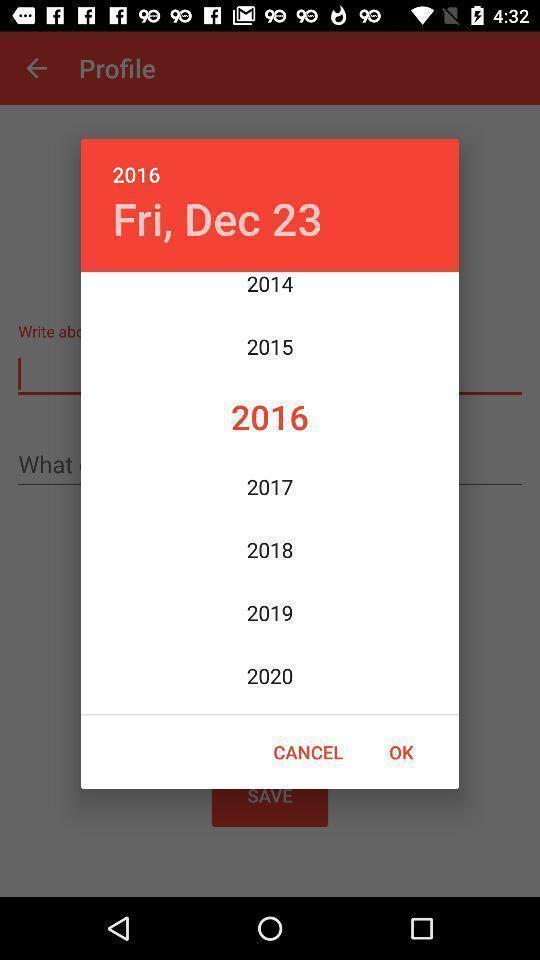Describe the visual elements of this screenshot. Pop-up showing the option to choose the year. 